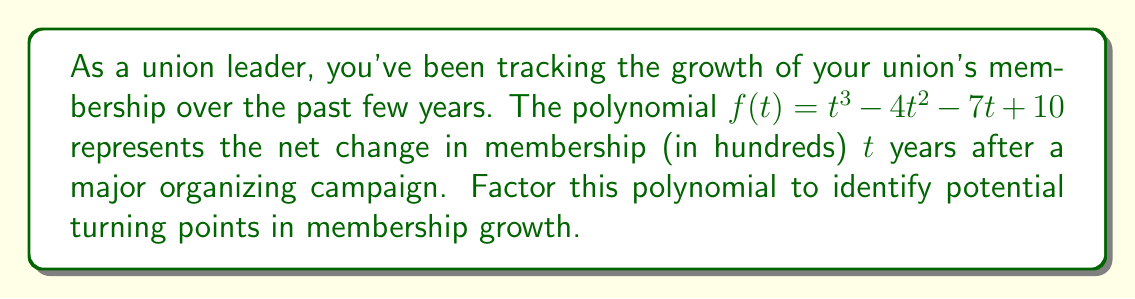What is the answer to this math problem? Let's approach this step-by-step:

1) First, we'll check if there are any rational roots using the rational root theorem. The possible rational roots are the factors of the constant term: ±1, ±2, ±5, ±10.

2) Testing these values, we find that $f(1) = 0$. So $(t-1)$ is a factor.

3) We can use polynomial long division to divide $f(t)$ by $(t-1)$:

   $$\frac{t^3 - 4t^2 - 7t + 10}{t-1} = t^2 - 3t - 10$$

4) Now we need to factor the quadratic $t^2 - 3t - 10$. We can do this by finding two numbers that multiply to give -10 and add to give -3. These numbers are -5 and 2.

5) So, $t^2 - 3t - 10 = (t-5)(t+2)$

6) Putting it all together, we have:

   $$f(t) = (t-1)(t-5)(t+2)$$

This factorization reveals that the membership growth has turning points at $t=1$, $t=5$, and $t=-2$ years after the campaign. As a union leader, you might interpret these as:

- After 1 year, there's a potential slowdown or reversal in growth.
- After 5 years, there's another significant change in membership trends.
- The negative value (-2 years) might represent a pre-campaign trend that was reversed.
Answer: $f(t) = (t-1)(t-5)(t+2)$ 